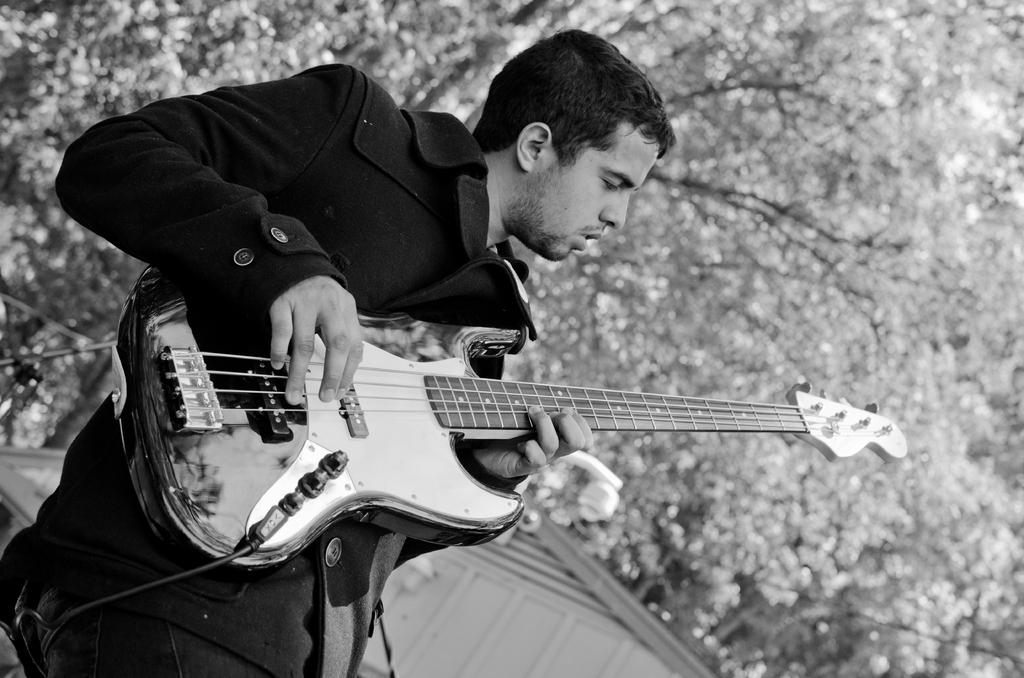Who is the main subject in the image? There is a man in the image. What is the man wearing? The man is wearing a black jacket. What is the man doing in the image? The man is playing a guitar. What type of natural element can be seen in the image? There is a tree visible in the image. What type of structure is visible in the image? There is a roof of a building in the image. Where is the list of items the man needs to buy located in the image? There is no list of items visible in the image. What type of juice is the man drinking in the image? There is no juice present in the image; the man is playing a guitar. 